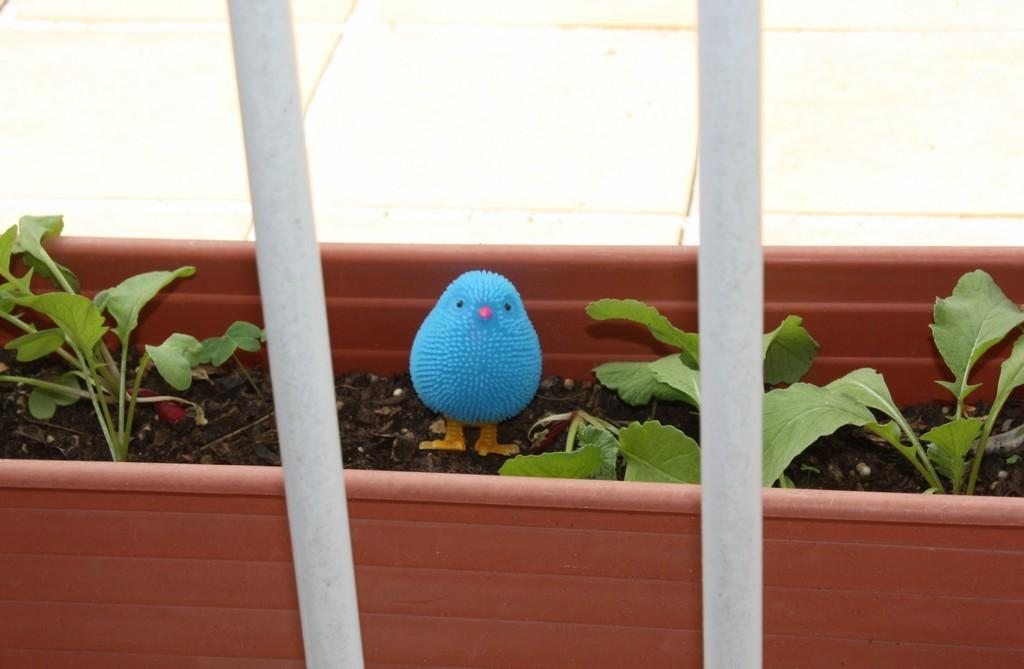What object is placed on the soil in the image? There is a toy bird on the soil in the image. What type of living organisms can be seen in the image? Plants are visible in the image. What is visible in the background of the image? There is a wall in the background of the image. What type of bun is being used to wash the business in the image? There is no bun, washing, or business present in the image. 